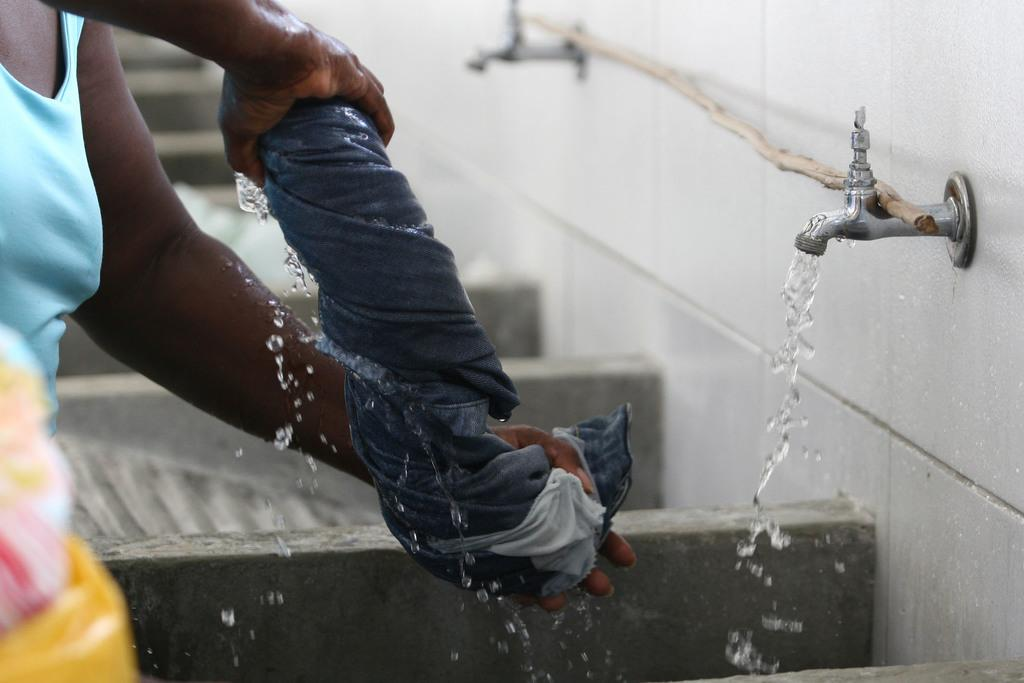Who is present in the image? There is a woman in the image. What is the woman holding in her hands? The woman is holding a cloth in her hands. What can be seen near the woman? There are taps in the image. What object is present in the image that is not related to water? There is a stick in the image. What is visible in the background of the image? There is a wall in the background of the image. What verse is being recited by the woman in the image? There is no indication in the image that the woman is reciting a verse, so it cannot be determined from the picture. 